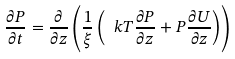Convert formula to latex. <formula><loc_0><loc_0><loc_500><loc_500>\frac { \partial P } { \partial t } = \frac { \partial } { \partial z } \left ( \frac { 1 } { \xi } \left ( \ k T \frac { \partial P } { \partial z } + P \frac { \partial U } { \partial z } \right ) \right )</formula> 